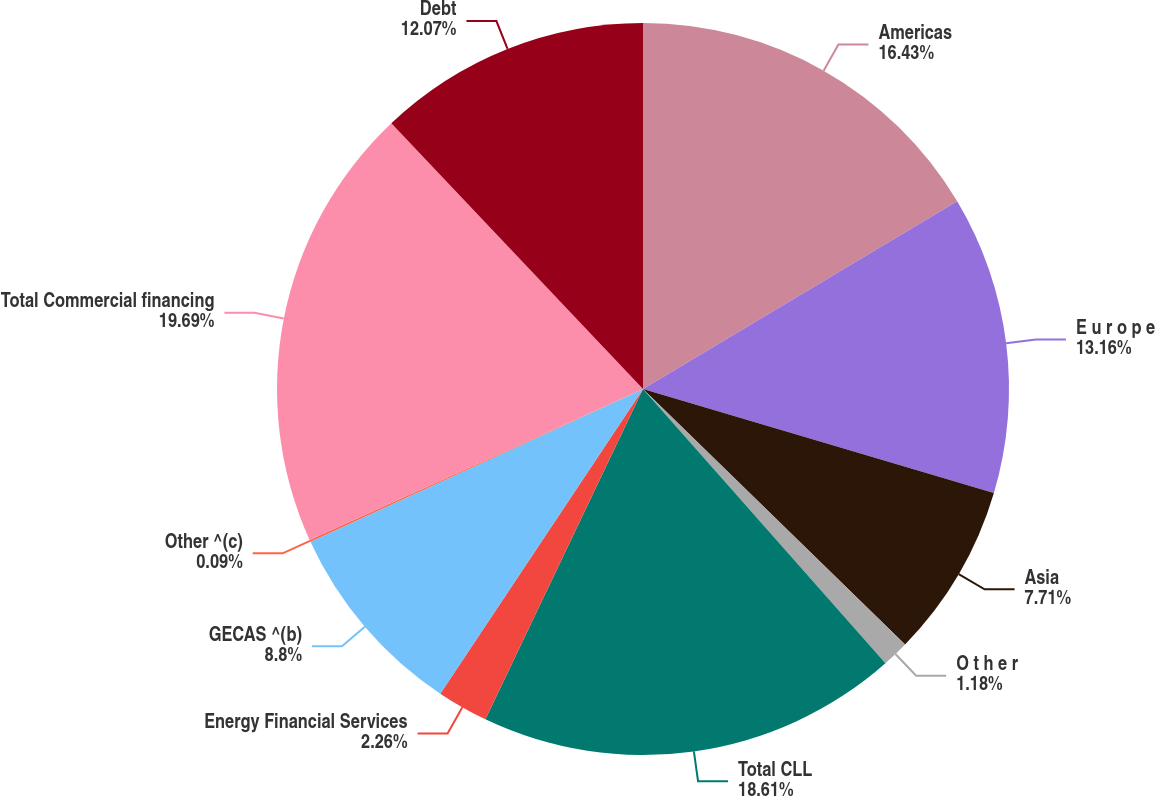Convert chart to OTSL. <chart><loc_0><loc_0><loc_500><loc_500><pie_chart><fcel>Americas<fcel>E u r o p e<fcel>Asia<fcel>O t h e r<fcel>Total CLL<fcel>Energy Financial Services<fcel>GECAS ^(b)<fcel>Other ^(c)<fcel>Total Commercial financing<fcel>Debt<nl><fcel>16.43%<fcel>13.16%<fcel>7.71%<fcel>1.18%<fcel>18.61%<fcel>2.26%<fcel>8.8%<fcel>0.09%<fcel>19.7%<fcel>12.07%<nl></chart> 